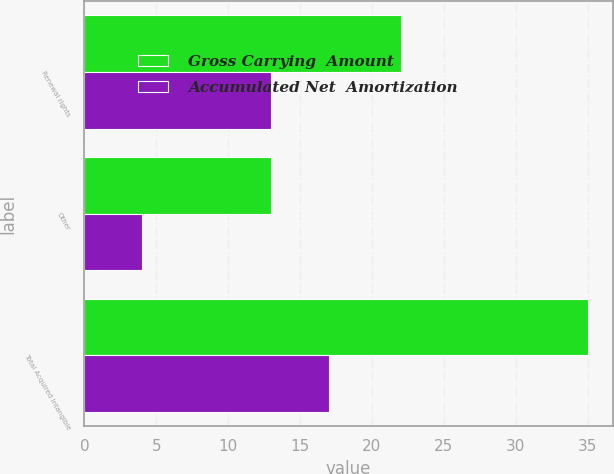Convert chart. <chart><loc_0><loc_0><loc_500><loc_500><stacked_bar_chart><ecel><fcel>Renewal rights<fcel>Other<fcel>Total Acquired Intangible<nl><fcel>Gross Carrying  Amount<fcel>22<fcel>13<fcel>35<nl><fcel>Accumulated Net  Amortization<fcel>13<fcel>4<fcel>17<nl></chart> 